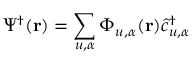Convert formula to latex. <formula><loc_0><loc_0><loc_500><loc_500>\Psi ^ { \dagger } ( { r } ) = \sum _ { u , \alpha } \Phi _ { u , \alpha } ( { r } ) \hat { c } _ { u , \alpha } ^ { \dagger }</formula> 